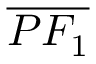<formula> <loc_0><loc_0><loc_500><loc_500>\overline { { P F _ { 1 } } }</formula> 